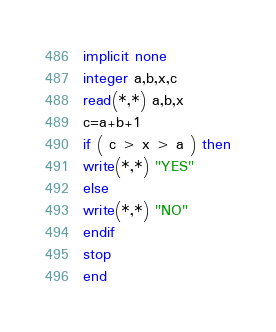Convert code to text. <code><loc_0><loc_0><loc_500><loc_500><_FORTRAN_>implicit none
integer a,b,x,c
read(*,*) a,b,x
c=a+b+1
if ( c > x > a ) then
write(*,*) "YES"
else
write(*,*) "NO"
endif
stop
end</code> 